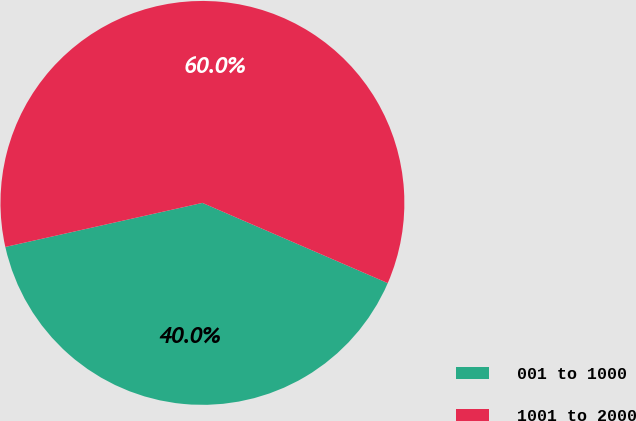Convert chart to OTSL. <chart><loc_0><loc_0><loc_500><loc_500><pie_chart><fcel>001 to 1000<fcel>1001 to 2000<nl><fcel>40.0%<fcel>60.0%<nl></chart> 